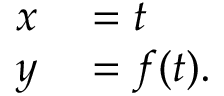Convert formula to latex. <formula><loc_0><loc_0><loc_500><loc_500>\begin{array} { r l } { x } & = t } \\ { y } & = f ( t ) . } \end{array}</formula> 